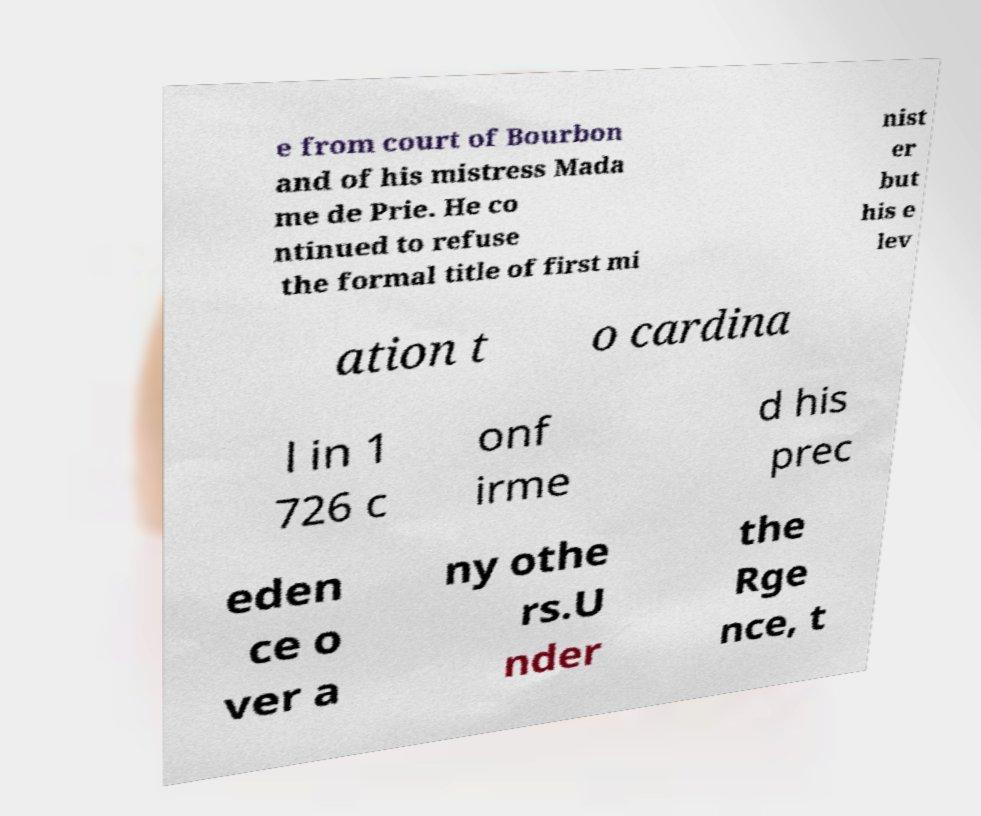Could you assist in decoding the text presented in this image and type it out clearly? e from court of Bourbon and of his mistress Mada me de Prie. He co ntinued to refuse the formal title of first mi nist er but his e lev ation t o cardina l in 1 726 c onf irme d his prec eden ce o ver a ny othe rs.U nder the Rge nce, t 